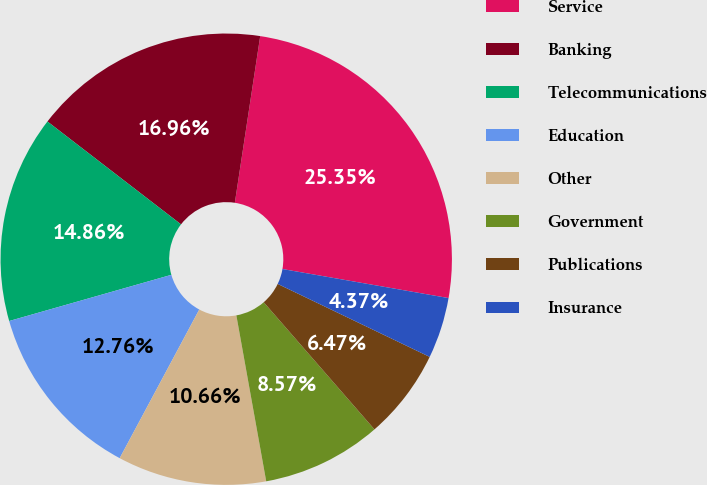Convert chart to OTSL. <chart><loc_0><loc_0><loc_500><loc_500><pie_chart><fcel>Service<fcel>Banking<fcel>Telecommunications<fcel>Education<fcel>Other<fcel>Government<fcel>Publications<fcel>Insurance<nl><fcel>25.35%<fcel>16.96%<fcel>14.86%<fcel>12.76%<fcel>10.66%<fcel>8.57%<fcel>6.47%<fcel>4.37%<nl></chart> 